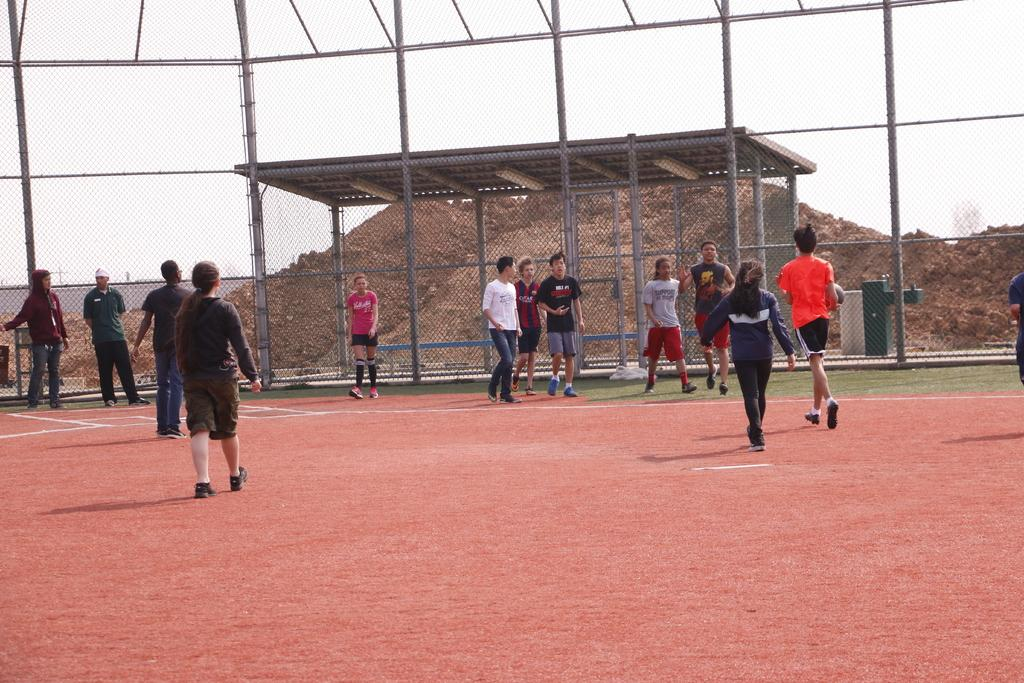What are the people in the image doing? The people in the image are walking. What can be seen under the people's feet in the image? The ground is visible in the image. What type of barrier is present in the image? There is fencing in the image. What is visible above the people's heads in the image? The sky is visible in the image. What type of suit is the horse wearing in the image? There is no horse or suit present in the image. How many crows are sitting on the fencing in the image? There are no crows present in the image. 